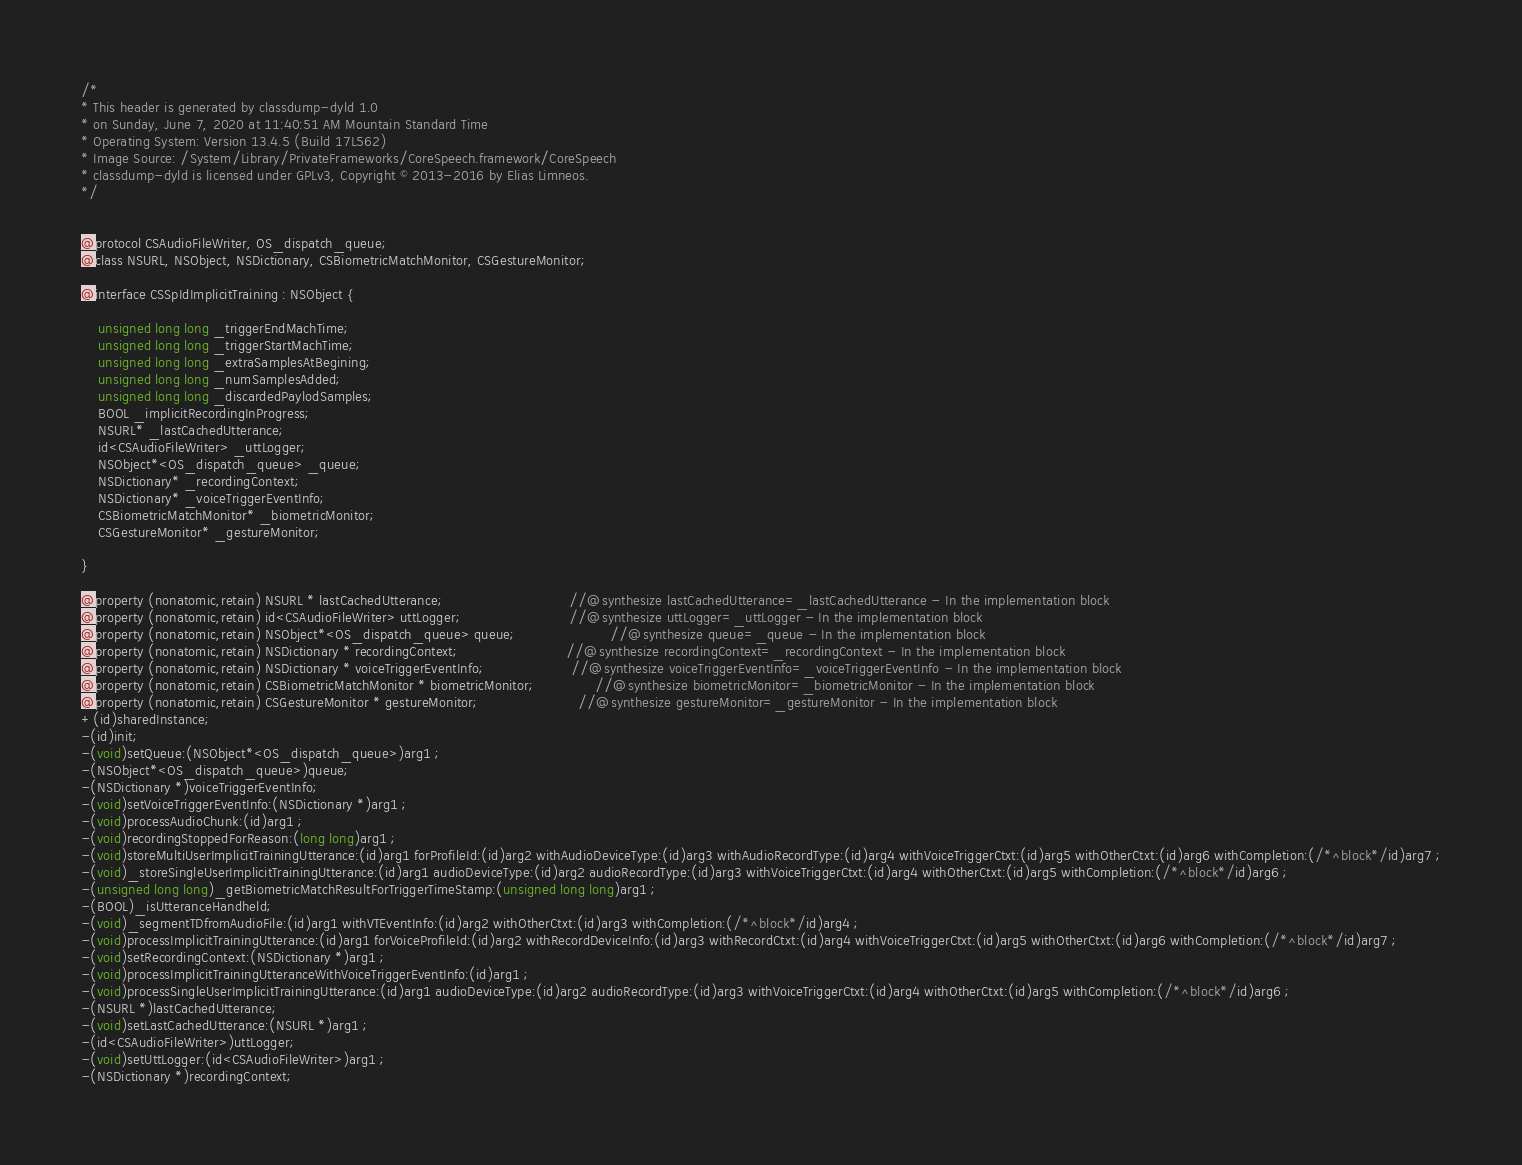<code> <loc_0><loc_0><loc_500><loc_500><_C_>/*
* This header is generated by classdump-dyld 1.0
* on Sunday, June 7, 2020 at 11:40:51 AM Mountain Standard Time
* Operating System: Version 13.4.5 (Build 17L562)
* Image Source: /System/Library/PrivateFrameworks/CoreSpeech.framework/CoreSpeech
* classdump-dyld is licensed under GPLv3, Copyright © 2013-2016 by Elias Limneos.
*/


@protocol CSAudioFileWriter, OS_dispatch_queue;
@class NSURL, NSObject, NSDictionary, CSBiometricMatchMonitor, CSGestureMonitor;

@interface CSSpIdImplicitTraining : NSObject {

	unsigned long long _triggerEndMachTime;
	unsigned long long _triggerStartMachTime;
	unsigned long long _extraSamplesAtBegining;
	unsigned long long _numSamplesAdded;
	unsigned long long _discardedPaylodSamples;
	BOOL _implicitRecordingInProgress;
	NSURL* _lastCachedUtterance;
	id<CSAudioFileWriter> _uttLogger;
	NSObject*<OS_dispatch_queue> _queue;
	NSDictionary* _recordingContext;
	NSDictionary* _voiceTriggerEventInfo;
	CSBiometricMatchMonitor* _biometricMonitor;
	CSGestureMonitor* _gestureMonitor;

}

@property (nonatomic,retain) NSURL * lastCachedUtterance;                             //@synthesize lastCachedUtterance=_lastCachedUtterance - In the implementation block
@property (nonatomic,retain) id<CSAudioFileWriter> uttLogger;                         //@synthesize uttLogger=_uttLogger - In the implementation block
@property (nonatomic,retain) NSObject*<OS_dispatch_queue> queue;                      //@synthesize queue=_queue - In the implementation block
@property (nonatomic,retain) NSDictionary * recordingContext;                         //@synthesize recordingContext=_recordingContext - In the implementation block
@property (nonatomic,retain) NSDictionary * voiceTriggerEventInfo;                    //@synthesize voiceTriggerEventInfo=_voiceTriggerEventInfo - In the implementation block
@property (nonatomic,retain) CSBiometricMatchMonitor * biometricMonitor;              //@synthesize biometricMonitor=_biometricMonitor - In the implementation block
@property (nonatomic,retain) CSGestureMonitor * gestureMonitor;                       //@synthesize gestureMonitor=_gestureMonitor - In the implementation block
+(id)sharedInstance;
-(id)init;
-(void)setQueue:(NSObject*<OS_dispatch_queue>)arg1 ;
-(NSObject*<OS_dispatch_queue>)queue;
-(NSDictionary *)voiceTriggerEventInfo;
-(void)setVoiceTriggerEventInfo:(NSDictionary *)arg1 ;
-(void)processAudioChunk:(id)arg1 ;
-(void)recordingStoppedForReason:(long long)arg1 ;
-(void)storeMultiUserImplicitTrainingUtterance:(id)arg1 forProfileId:(id)arg2 withAudioDeviceType:(id)arg3 withAudioRecordType:(id)arg4 withVoiceTriggerCtxt:(id)arg5 withOtherCtxt:(id)arg6 withCompletion:(/*^block*/id)arg7 ;
-(void)_storeSingleUserImplicitTrainingUtterance:(id)arg1 audioDeviceType:(id)arg2 audioRecordType:(id)arg3 withVoiceTriggerCtxt:(id)arg4 withOtherCtxt:(id)arg5 withCompletion:(/*^block*/id)arg6 ;
-(unsigned long long)_getBiometricMatchResultForTriggerTimeStamp:(unsigned long long)arg1 ;
-(BOOL)_isUtteranceHandheld;
-(void)_segmentTDfromAudioFile:(id)arg1 withVTEventInfo:(id)arg2 withOtherCtxt:(id)arg3 withCompletion:(/*^block*/id)arg4 ;
-(void)processImplicitTrainingUtterance:(id)arg1 forVoiceProfileId:(id)arg2 withRecordDeviceInfo:(id)arg3 withRecordCtxt:(id)arg4 withVoiceTriggerCtxt:(id)arg5 withOtherCtxt:(id)arg6 withCompletion:(/*^block*/id)arg7 ;
-(void)setRecordingContext:(NSDictionary *)arg1 ;
-(void)processImplicitTrainingUtteranceWithVoiceTriggerEventInfo:(id)arg1 ;
-(void)processSingleUserImplicitTrainingUtterance:(id)arg1 audioDeviceType:(id)arg2 audioRecordType:(id)arg3 withVoiceTriggerCtxt:(id)arg4 withOtherCtxt:(id)arg5 withCompletion:(/*^block*/id)arg6 ;
-(NSURL *)lastCachedUtterance;
-(void)setLastCachedUtterance:(NSURL *)arg1 ;
-(id<CSAudioFileWriter>)uttLogger;
-(void)setUttLogger:(id<CSAudioFileWriter>)arg1 ;
-(NSDictionary *)recordingContext;</code> 